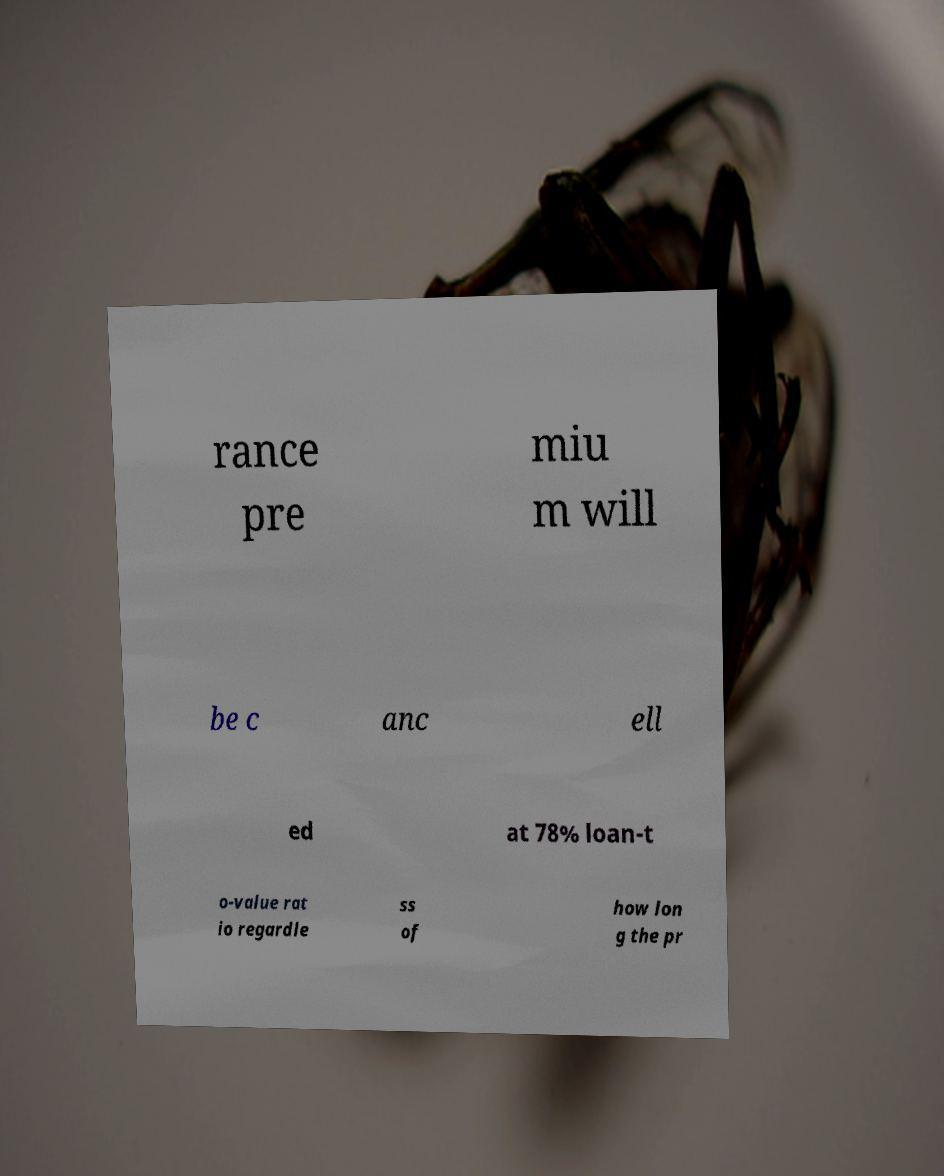Please read and relay the text visible in this image. What does it say? rance pre miu m will be c anc ell ed at 78% loan-t o-value rat io regardle ss of how lon g the pr 